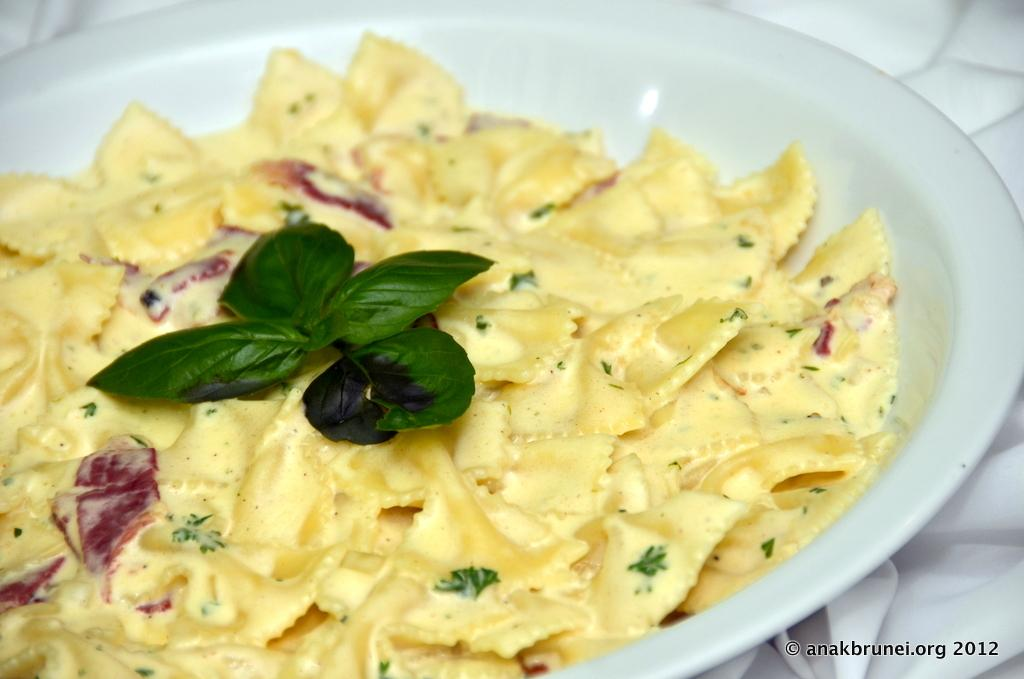What is present on the plate in the image? There is a plate in the image, and it has flakes and leaf garnish on it. What color is the plate? The plate is white in color. What color are the flakes on the plate? The flakes on the plate are light yellow in color. Can you see a donkey eating a twig on the plate in the image? No, there is no donkey or twig present on the plate in the image. Is there any salt visible on the plate in the image? There is no mention of salt in the provided facts, so we cannot determine if it is present on the plate. 